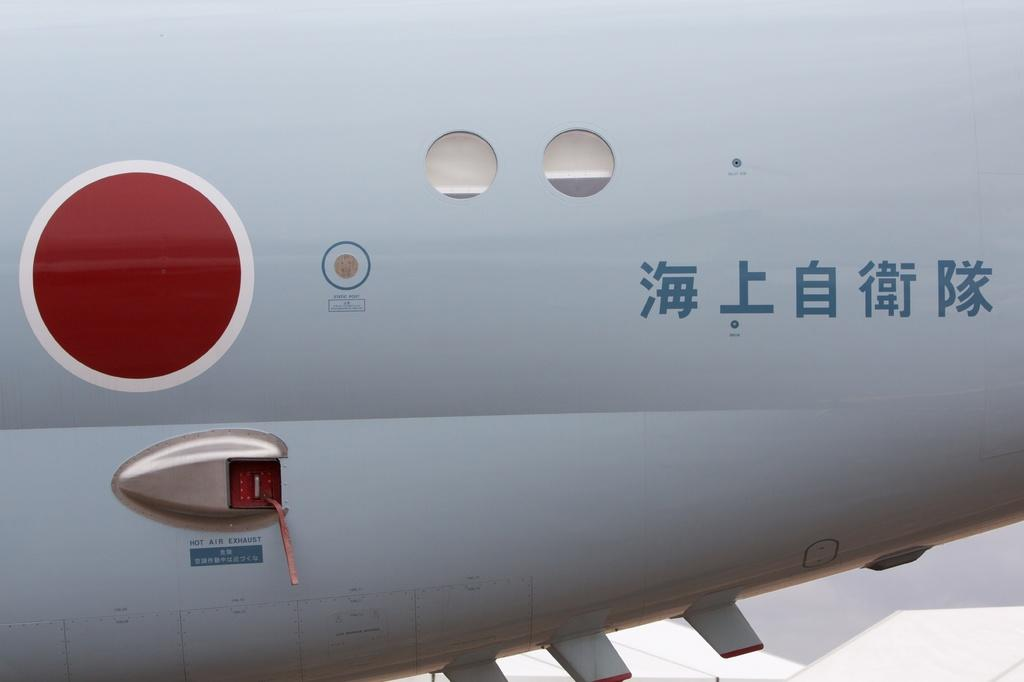What type of landscape is depicted in the image? The image shows the back part of a plain. Are there any specific features on the plain? Yes, there are windows on the plain. Can you describe the round shape with red color in the image? There is a round shape with red color filled in it. What else can be seen on the plain? There is an item on the plain. How many snails can be seen crawling on the plain in the image? There are no snails visible in the image. What type of judgment is being made by the judge in the image? There is no judge present in the image. 